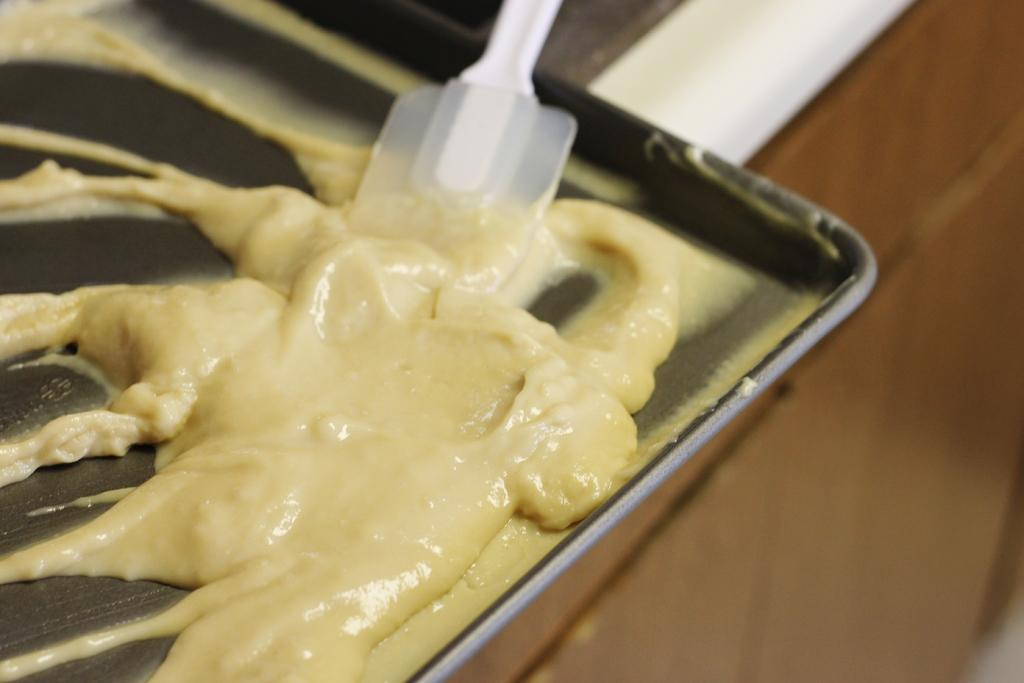What object is present in the image that can be used for holding items? There is a tray in the image that can be used for holding items. What is on the tray in the image? The tray contains a spoon and cream. Where is the tray located in the image? The tray is placed on a platform. How many chickens are standing on the tray in the image? There are no chickens present on the tray or in the image. 